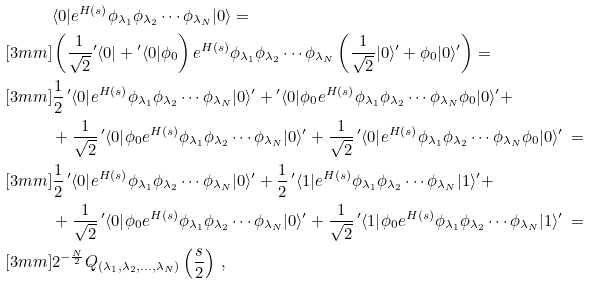<formula> <loc_0><loc_0><loc_500><loc_500>& \langle 0 | e ^ { H ( s ) } \phi _ { \lambda _ { 1 } } \phi _ { \lambda _ { 2 } } \cdots \phi _ { \lambda _ { N } } | 0 \rangle = \\ [ 3 m m ] & \left ( \frac { 1 } { \sqrt { 2 } } { ^ { \prime } \langle 0 | } + { ^ { \prime } \langle 0 | } \phi _ { 0 } \right ) e ^ { H ( s ) } \phi _ { \lambda _ { 1 } } \phi _ { \lambda _ { 2 } } \cdots \phi _ { \lambda _ { N } } \left ( \frac { 1 } { \sqrt { 2 } } | 0 \rangle ^ { \prime } + \phi _ { 0 } | 0 \rangle ^ { \prime } \right ) = \\ [ 3 m m ] & \frac { 1 } { 2 } \, { ^ { \prime } \langle 0 | } e ^ { H ( s ) } \phi _ { \lambda _ { 1 } } \phi _ { \lambda _ { 2 } } \cdots \phi _ { \lambda _ { N } } | 0 \rangle ^ { \prime } + { ^ { \prime } \langle 0 | } \phi _ { 0 } e ^ { H ( s ) } \phi _ { \lambda _ { 1 } } \phi _ { \lambda _ { 2 } } \cdots \phi _ { \lambda _ { N } } \phi _ { 0 } | 0 \rangle ^ { \prime } + \\ & + \frac { 1 } { \sqrt { 2 } } \, { ^ { \prime } \langle 0 | } \phi _ { 0 } e ^ { H ( s ) } \phi _ { \lambda _ { 1 } } \phi _ { \lambda _ { 2 } } \cdots \phi _ { \lambda _ { N } } | 0 \rangle ^ { \prime } + \frac { 1 } { \sqrt { 2 } } \, { ^ { \prime } \langle 0 | } e ^ { H ( s ) } \phi _ { \lambda _ { 1 } } \phi _ { \lambda _ { 2 } } \cdots \phi _ { \lambda _ { N } } \phi _ { 0 } | 0 \rangle ^ { \prime } \, = \\ [ 3 m m ] & \frac { 1 } { 2 } \, { ^ { \prime } \langle 0 | } e ^ { H ( s ) } \phi _ { \lambda _ { 1 } } \phi _ { \lambda _ { 2 } } \cdots \phi _ { \lambda _ { N } } | 0 \rangle ^ { \prime } + \frac { 1 } { 2 } \, { ^ { \prime } \langle 1 | } e ^ { H ( s ) } \phi _ { \lambda _ { 1 } } \phi _ { \lambda _ { 2 } } \cdots \phi _ { \lambda _ { N } } | 1 \rangle ^ { \prime } + \\ & + \frac { 1 } { \sqrt { 2 } } \, { ^ { \prime } \langle 0 | } \phi _ { 0 } e ^ { H ( s ) } \phi _ { \lambda _ { 1 } } \phi _ { \lambda _ { 2 } } \cdots \phi _ { \lambda _ { N } } | 0 \rangle ^ { \prime } + \frac { 1 } { \sqrt { 2 } } \, { ^ { \prime } \langle 1 | } \phi _ { 0 } e ^ { H ( s ) } \phi _ { \lambda _ { 1 } } \phi _ { \lambda _ { 2 } } \cdots \phi _ { \lambda _ { N } } | 1 \rangle ^ { \prime } \, = \\ [ 3 m m ] & 2 ^ { - \frac { N } 2 } Q _ { ( \lambda _ { 1 } , { \lambda _ { 2 } } , \dots , { \lambda _ { N } } ) } \left ( \frac { s } 2 \right ) \, ,</formula> 